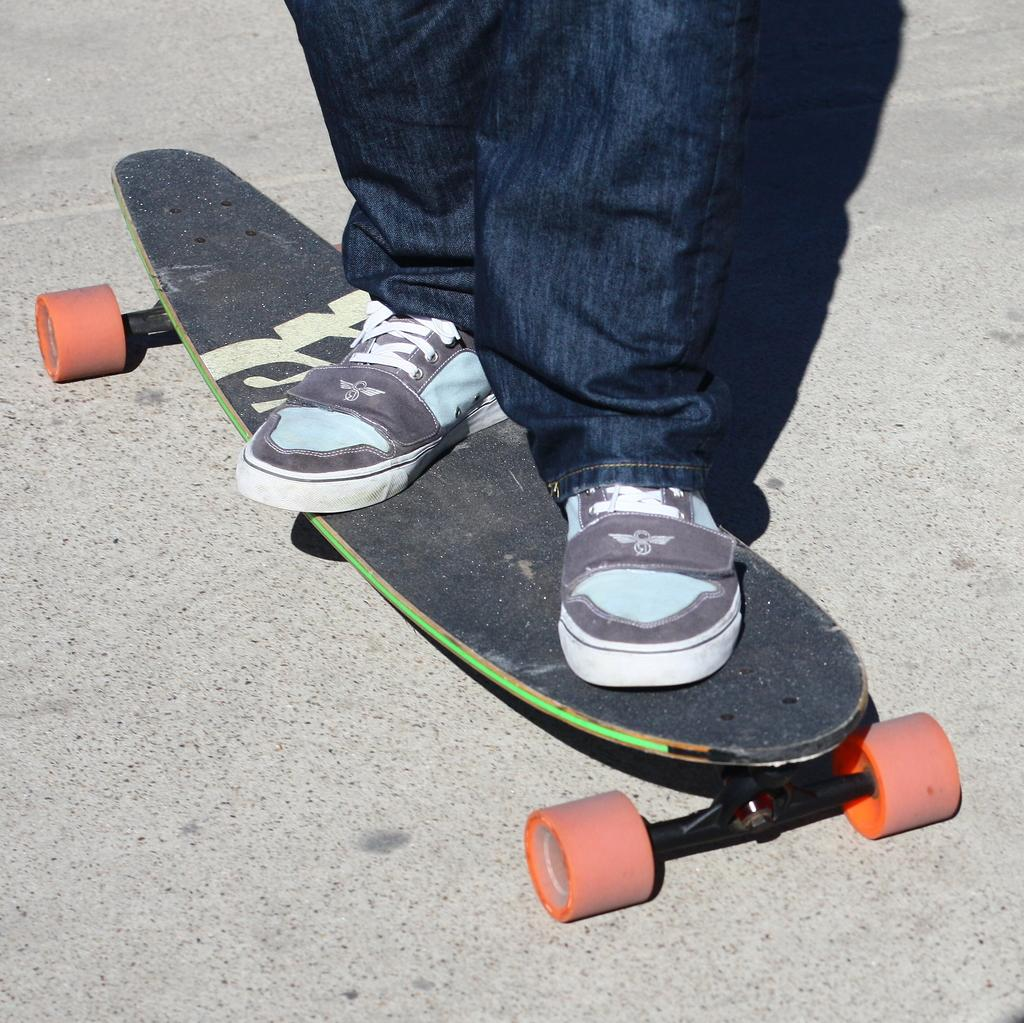What is the main subject of the image? There is a person in the image. What is the person doing in the image? The person is standing on a skateboard. Where is the skateboard located? The skateboard is on the road. What part of the person can be seen in the image? Only the person's legs are visible in the image. What type of map is the person holding in the image? There is no map present in the image; the person is standing on a skateboard with only their legs visible. 